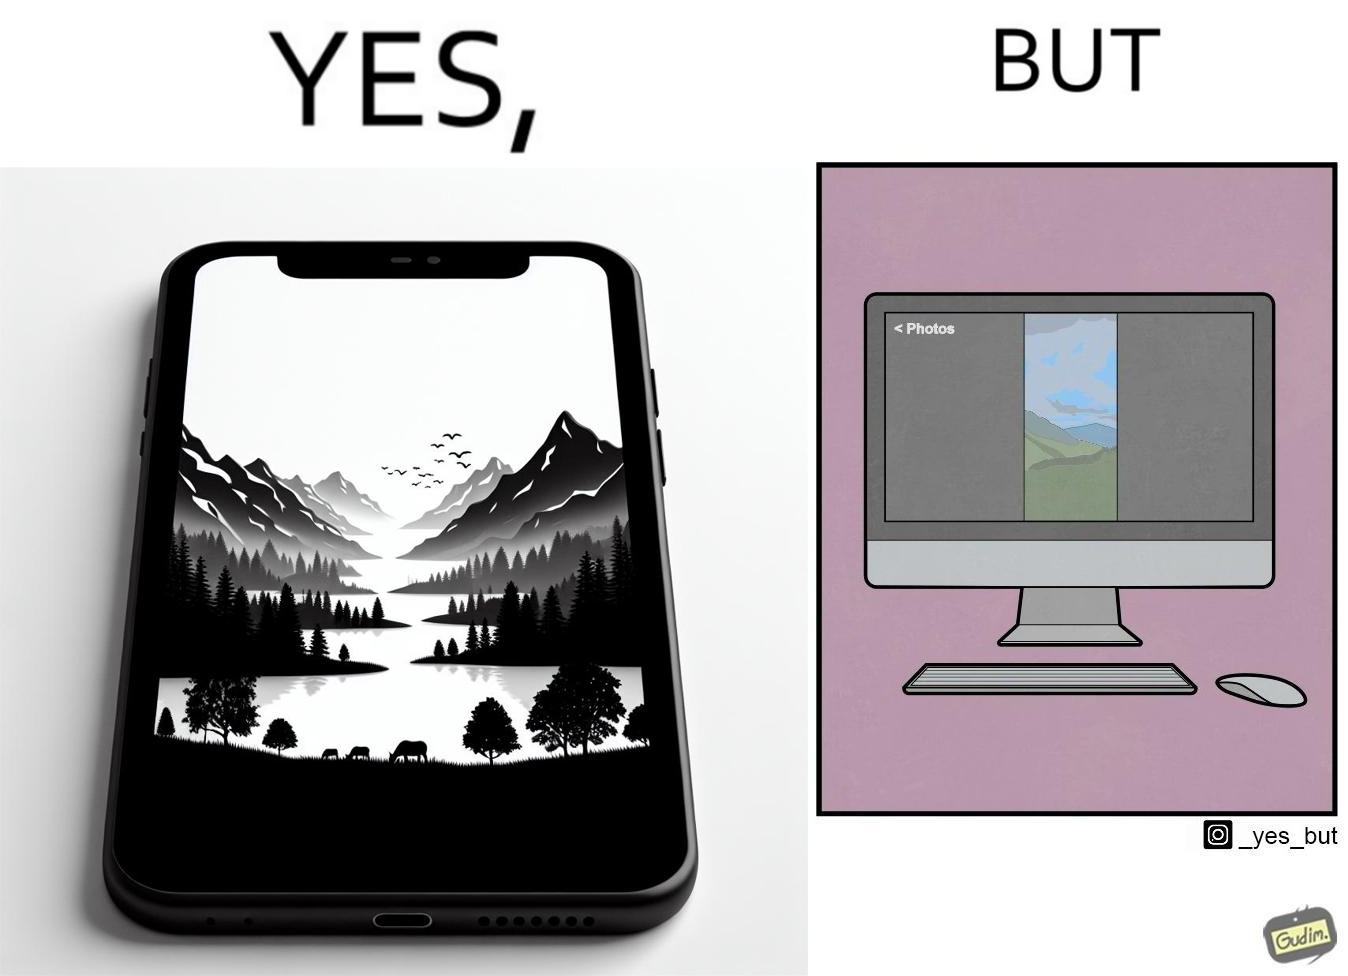Compare the left and right sides of this image. In the left part of the image: an image of a scenic view on mobile In the right part of the image: an image of a scenic view in portrait mode on a computer monitor. 